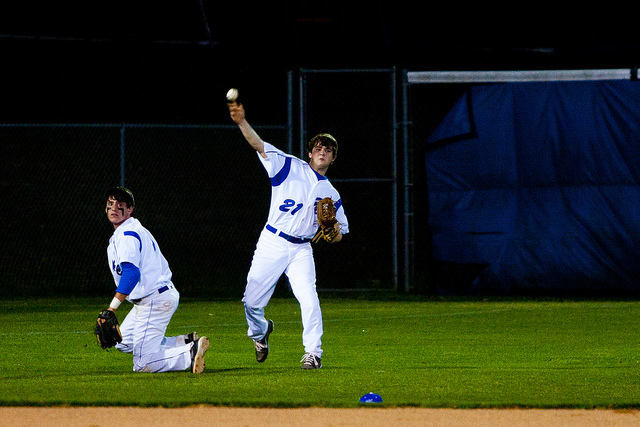<image>Why is he on his knees? I am not sure why he is on his knees. It could be because he fell or tried to catch a ball. What team is this player on? It's unclear what team the player is on without further context. It could be the Yankees, Ravens, Cubs, or Dodgers. Why is he on his knees? I don't know why he is on his knees. It can be because he fell or tried to catch a ball. What team is this player on? I am not sure what team this player is on. It can be either the Yankees, Ravens, Cubs, or Dodgers, as they are all mentioned in the answers. 